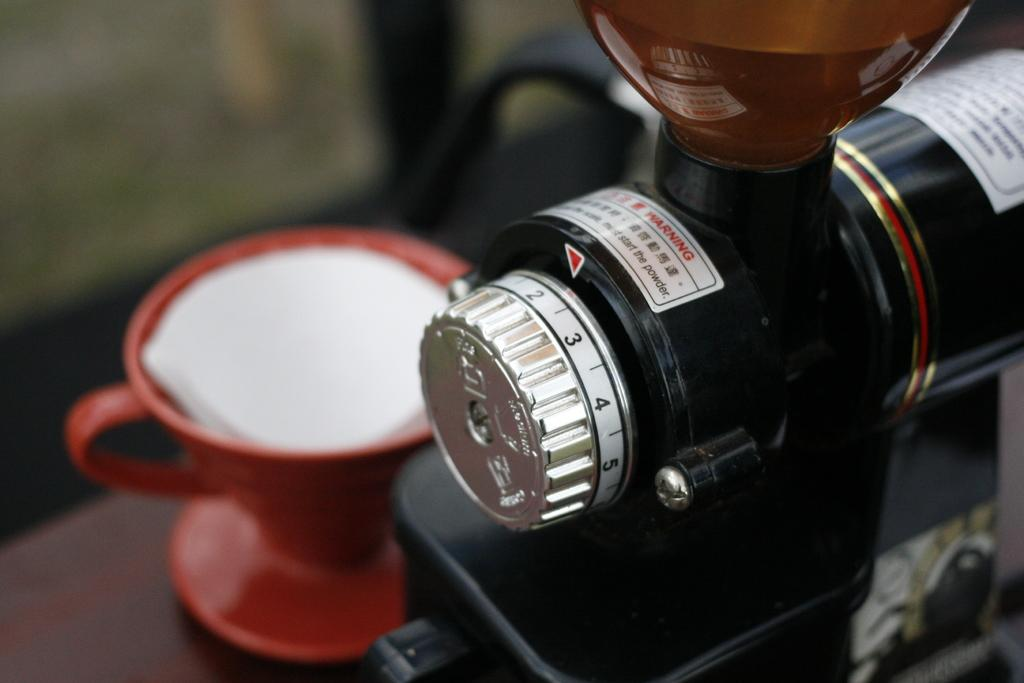What type of object is in the image that might be used for play? There is a toy in the image. What other object can be seen in the image that might be used for serving or drinking? There is a tea cup in the image. How many bikes are parked next to the toy in the image? There is no mention of bikes in the image; only a toy and a tea cup are present. What type of vehicle is visible in the image? There is no vehicle present in the image. 